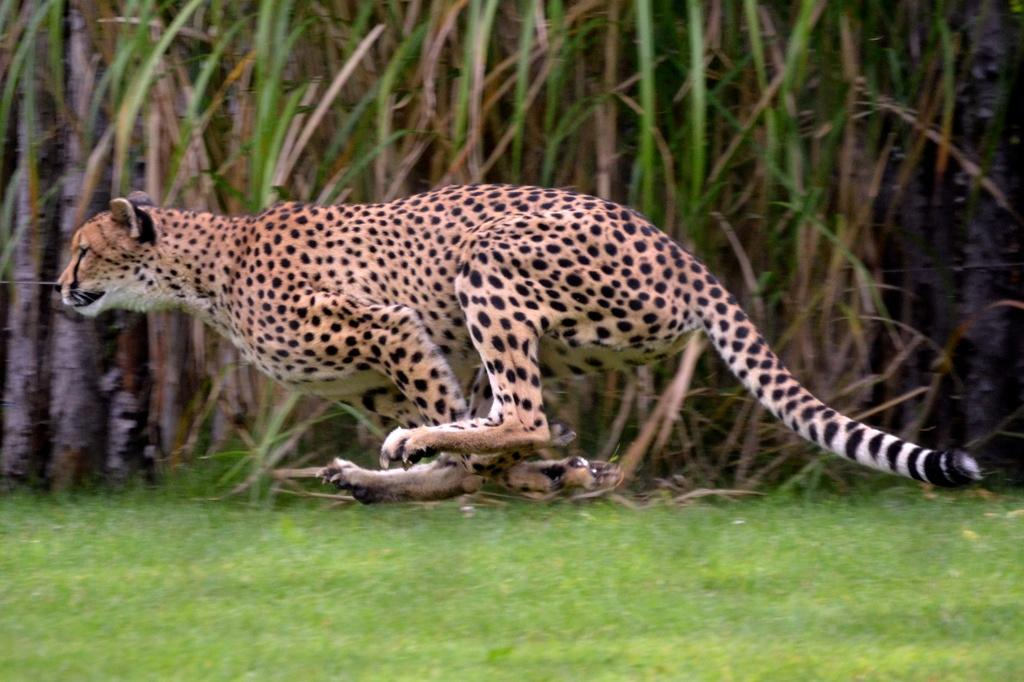What animal can be seen in the image? There is a leopard in the image. What is the leopard doing in the image? The leopard is running in the image. What type of terrain is visible in the image? There is grass on the ground in the image. What other vegetation can be seen in the image? There are plants visible in the image. What colors make up the leopard's fur? The leopard is white, yellow, and black in color. Can you see a chain of rice paddies in the image? There is no chain of rice paddies present in the image; it features a leopard running on grassy terrain. 